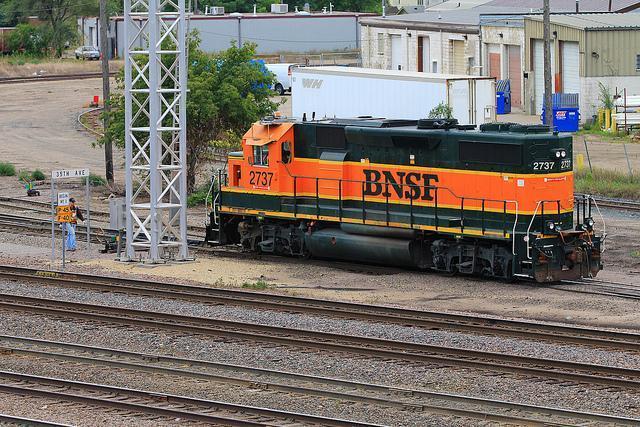How many trucks can be seen?
Give a very brief answer. 1. How many benches are there?
Give a very brief answer. 0. 